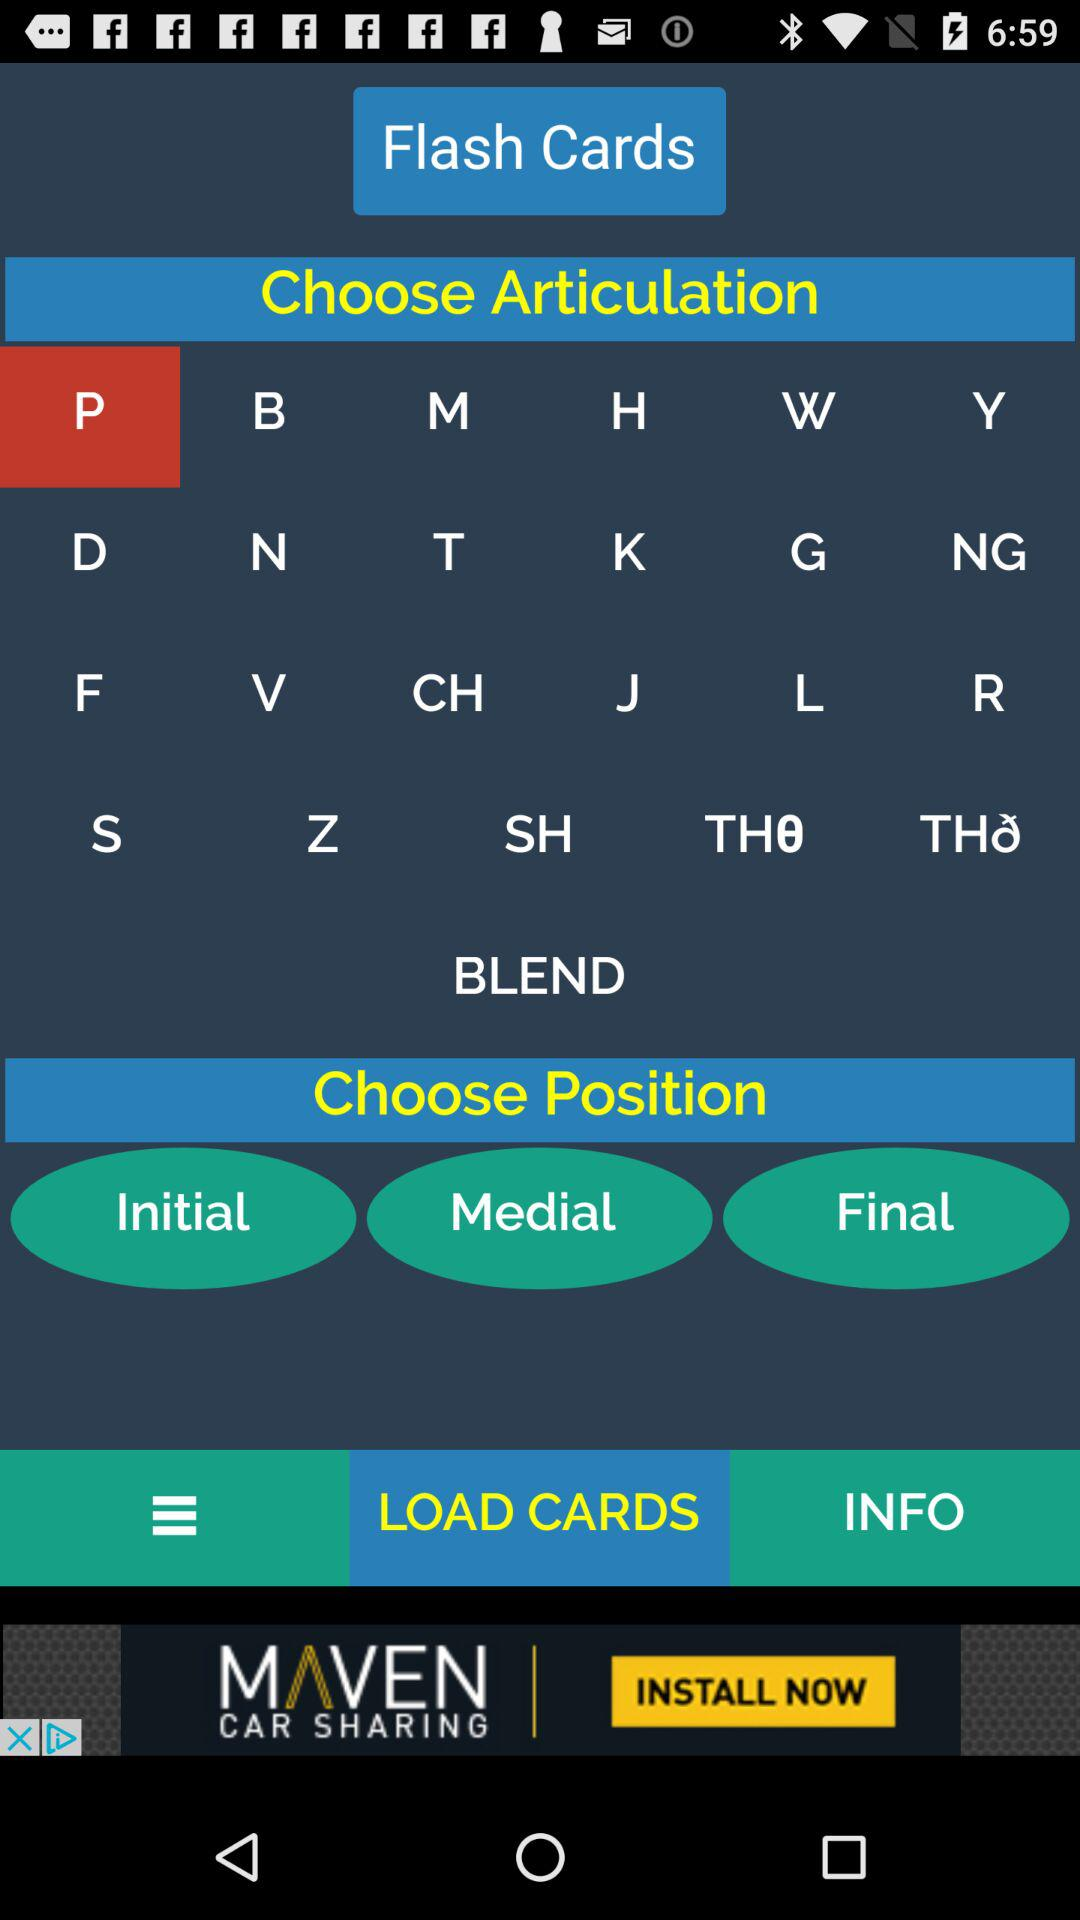Which tab has been selected? The tab "LOAD CARDS" has been selected. 